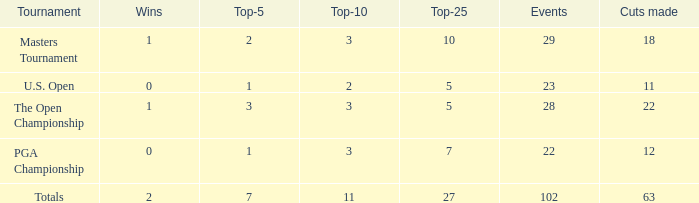How many vuts made for a player with 2 wins and under 7 top 5s? None. 